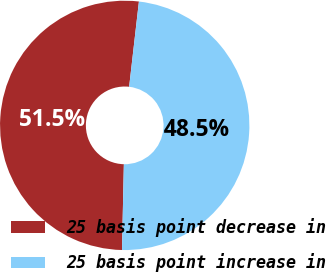Convert chart to OTSL. <chart><loc_0><loc_0><loc_500><loc_500><pie_chart><fcel>25 basis point decrease in<fcel>25 basis point increase in<nl><fcel>51.47%<fcel>48.53%<nl></chart> 